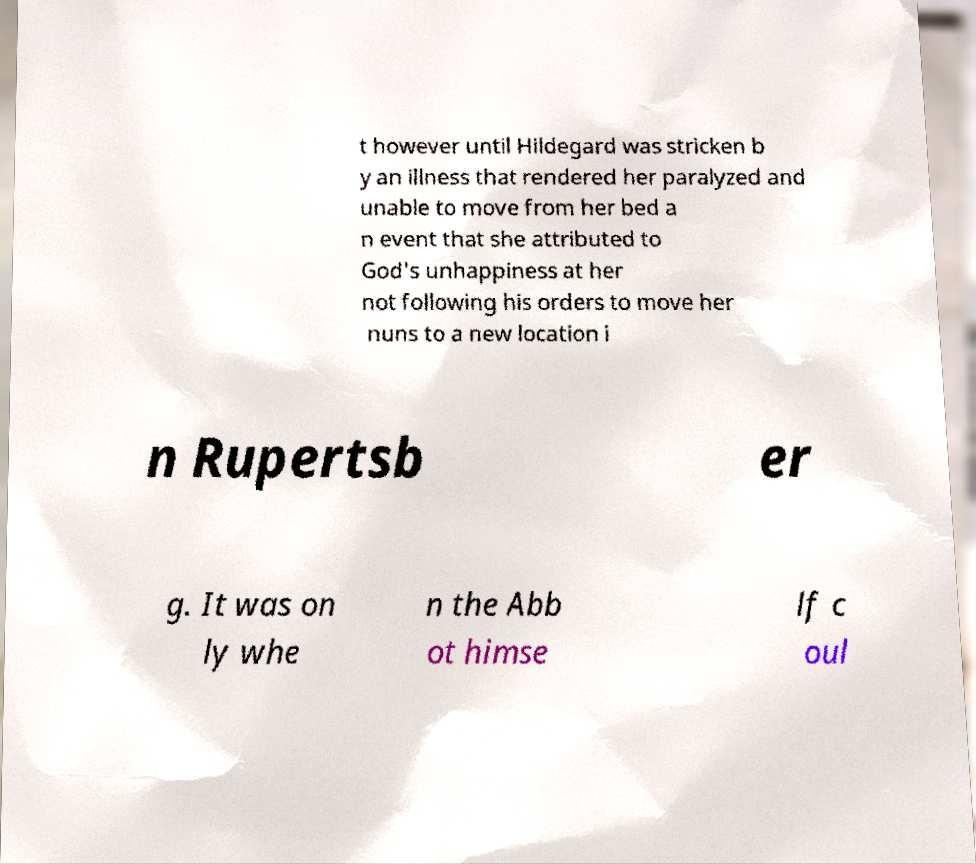Please read and relay the text visible in this image. What does it say? t however until Hildegard was stricken b y an illness that rendered her paralyzed and unable to move from her bed a n event that she attributed to God's unhappiness at her not following his orders to move her nuns to a new location i n Rupertsb er g. It was on ly whe n the Abb ot himse lf c oul 